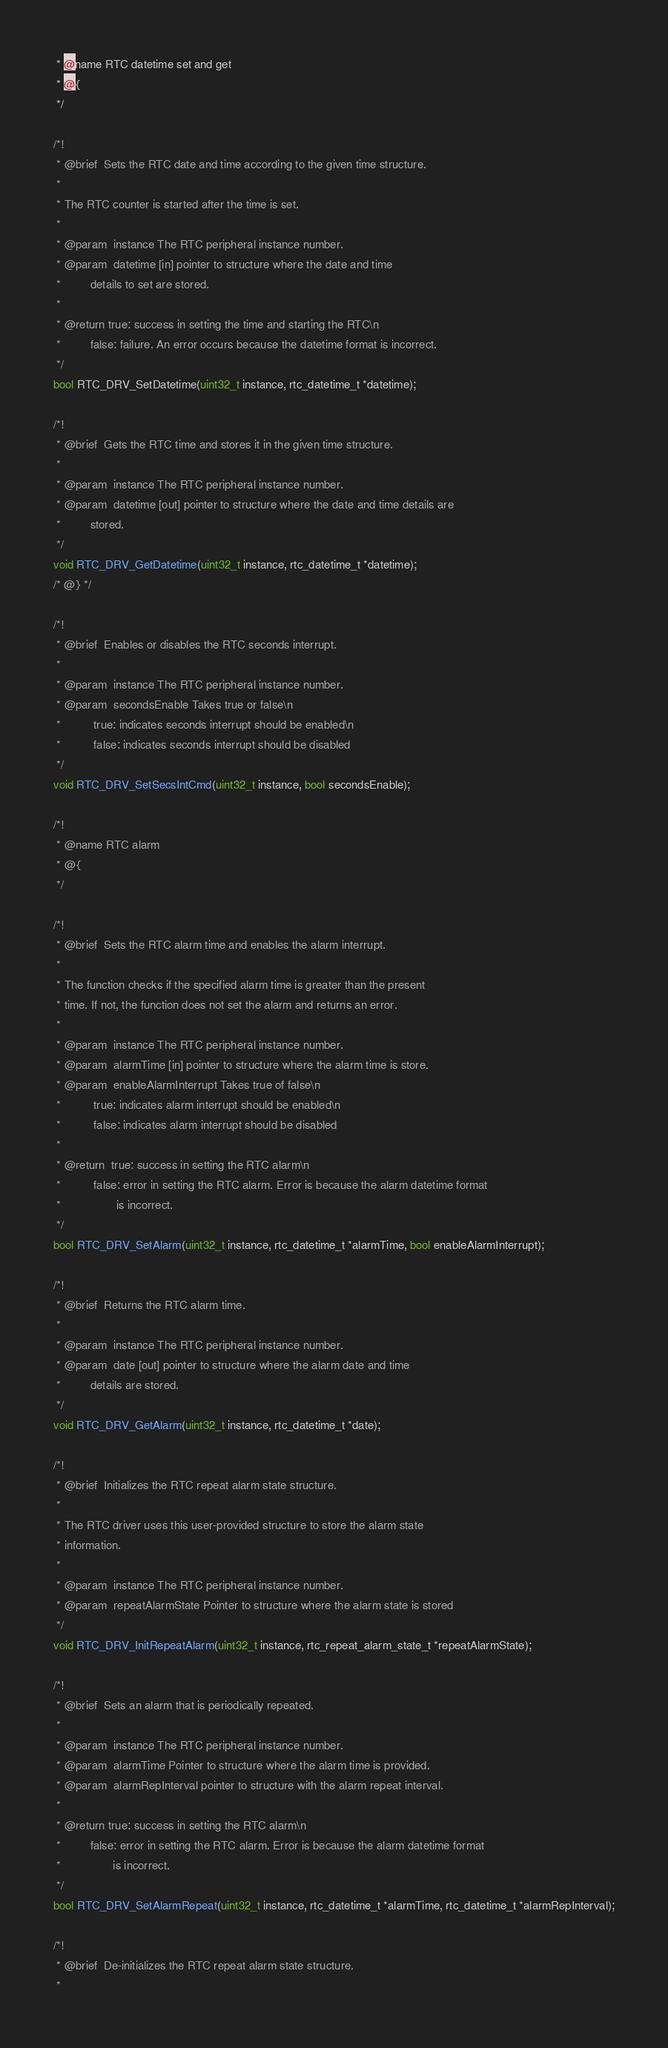<code> <loc_0><loc_0><loc_500><loc_500><_C_> * @name RTC datetime set and get
 * @{
 */

/*!
 * @brief  Sets the RTC date and time according to the given time structure.
 *
 * The RTC counter is started after the time is set.
 *
 * @param  instance The RTC peripheral instance number.
 * @param  datetime [in] pointer to structure where the date and time
 *         details to set are stored.
 *
 * @return true: success in setting the time and starting the RTC\n
 *         false: failure. An error occurs because the datetime format is incorrect.
 */
bool RTC_DRV_SetDatetime(uint32_t instance, rtc_datetime_t *datetime);

/*!
 * @brief  Gets the RTC time and stores it in the given time structure.
 *
 * @param  instance The RTC peripheral instance number.
 * @param  datetime [out] pointer to structure where the date and time details are
 *         stored.
 */
void RTC_DRV_GetDatetime(uint32_t instance, rtc_datetime_t *datetime);
/* @} */

/*!
 * @brief  Enables or disables the RTC seconds interrupt.
 *
 * @param  instance The RTC peripheral instance number.
 * @param  secondsEnable Takes true or false\n
 *          true: indicates seconds interrupt should be enabled\n
 *          false: indicates seconds interrupt should be disabled
 */
void RTC_DRV_SetSecsIntCmd(uint32_t instance, bool secondsEnable);

/*!
 * @name RTC alarm
 * @{
 */

/*!
 * @brief  Sets the RTC alarm time and enables the alarm interrupt.
 *
 * The function checks if the specified alarm time is greater than the present
 * time. If not, the function does not set the alarm and returns an error.
 *
 * @param  instance The RTC peripheral instance number.
 * @param  alarmTime [in] pointer to structure where the alarm time is store.
 * @param  enableAlarmInterrupt Takes true of false\n
 *          true: indicates alarm interrupt should be enabled\n
 *          false: indicates alarm interrupt should be disabled
 *
 * @return  true: success in setting the RTC alarm\n
 *          false: error in setting the RTC alarm. Error is because the alarm datetime format
 *                 is incorrect.
 */
bool RTC_DRV_SetAlarm(uint32_t instance, rtc_datetime_t *alarmTime, bool enableAlarmInterrupt);

/*!
 * @brief  Returns the RTC alarm time.
 *
 * @param  instance The RTC peripheral instance number.
 * @param  date [out] pointer to structure where the alarm date and time
 *         details are stored.
 */
void RTC_DRV_GetAlarm(uint32_t instance, rtc_datetime_t *date);

/*!
 * @brief  Initializes the RTC repeat alarm state structure.
 *
 * The RTC driver uses this user-provided structure to store the alarm state
 * information.
 *
 * @param  instance The RTC peripheral instance number.
 * @param  repeatAlarmState Pointer to structure where the alarm state is stored
 */
void RTC_DRV_InitRepeatAlarm(uint32_t instance, rtc_repeat_alarm_state_t *repeatAlarmState);

/*!
 * @brief  Sets an alarm that is periodically repeated.
 *
 * @param  instance The RTC peripheral instance number.
 * @param  alarmTime Pointer to structure where the alarm time is provided.
 * @param  alarmRepInterval pointer to structure with the alarm repeat interval.
 *
 * @return true: success in setting the RTC alarm\n
 *         false: error in setting the RTC alarm. Error is because the alarm datetime format
 *                is incorrect.
 */
bool RTC_DRV_SetAlarmRepeat(uint32_t instance, rtc_datetime_t *alarmTime, rtc_datetime_t *alarmRepInterval);

/*!
 * @brief  De-initializes the RTC repeat alarm state structure.
 *</code> 